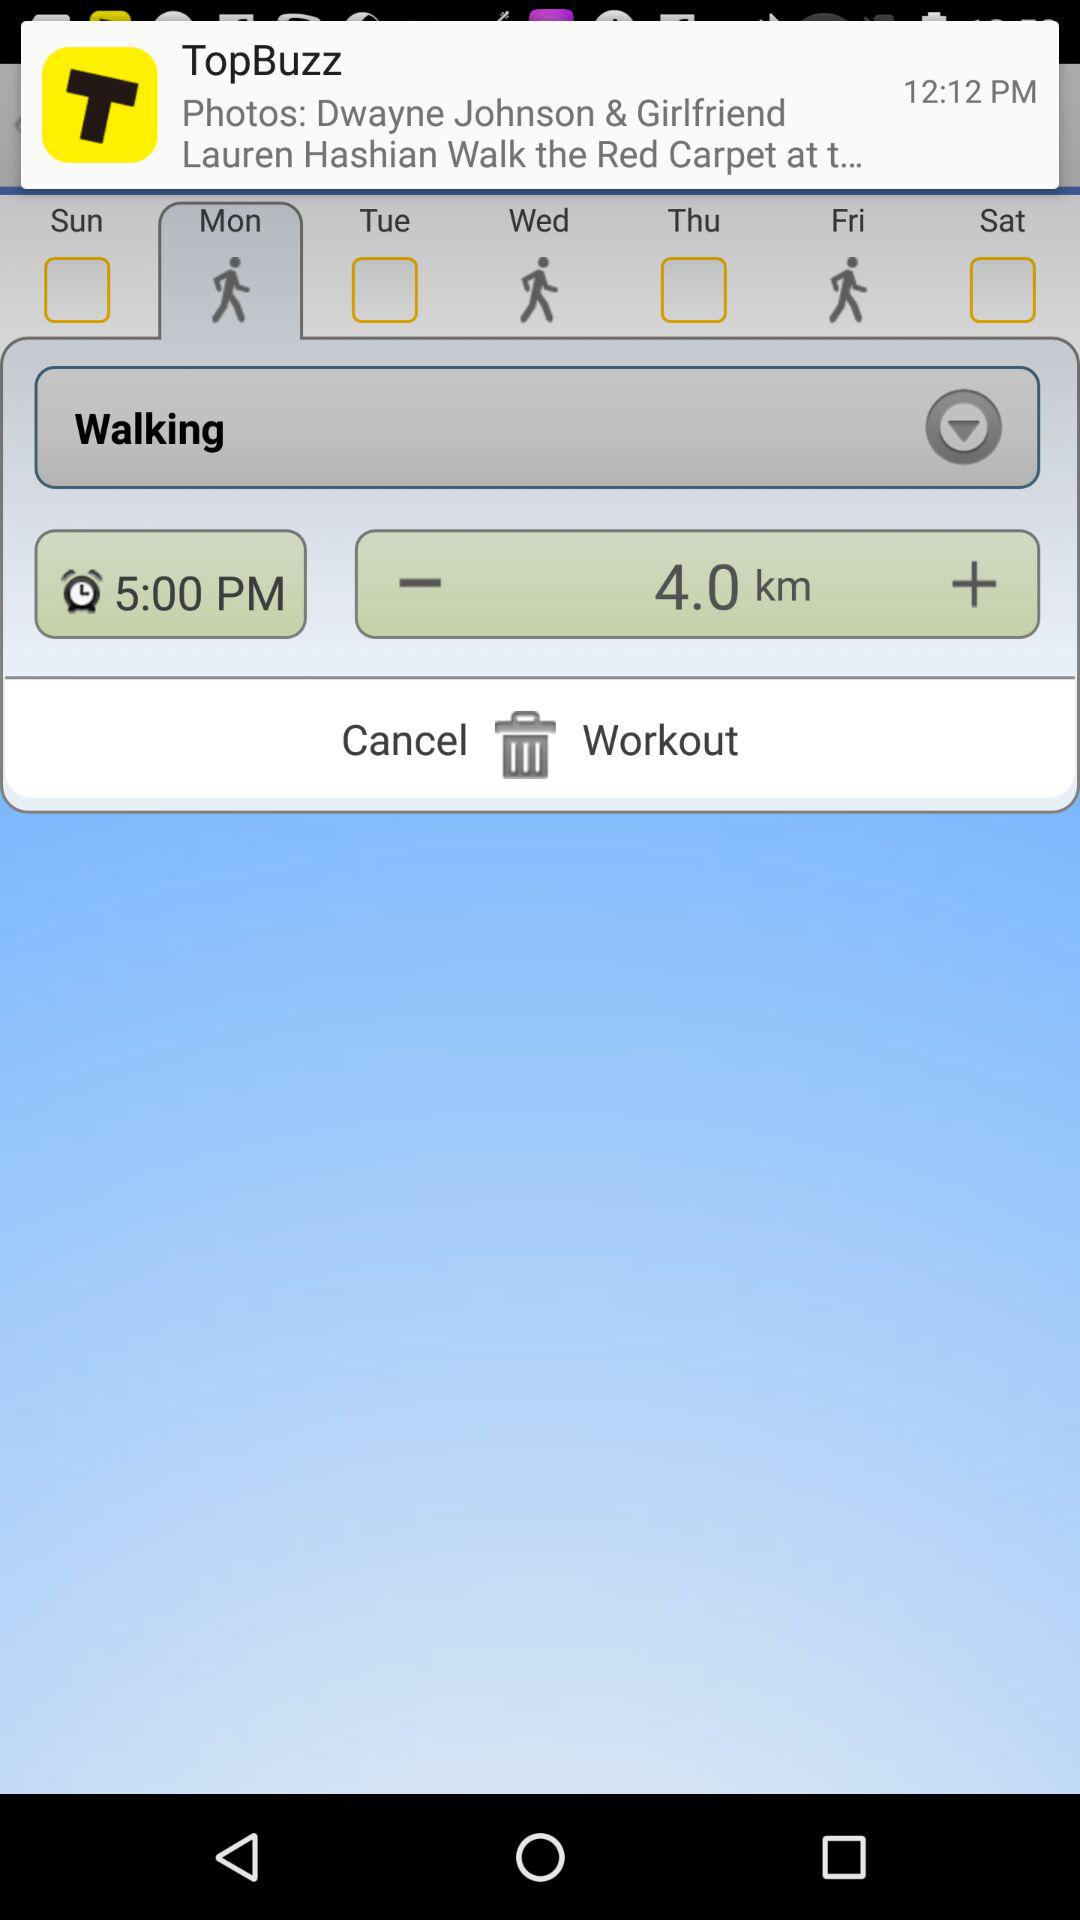What is the total distance of the workout?
Answer the question using a single word or phrase. 4.0 km 